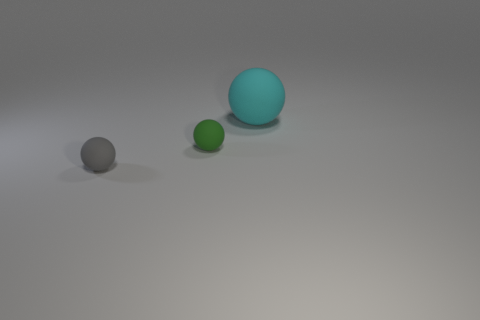Add 1 green rubber things. How many objects exist? 4 Subtract all large cyan matte things. Subtract all small blue cubes. How many objects are left? 2 Add 2 large objects. How many large objects are left? 3 Add 2 gray metal cylinders. How many gray metal cylinders exist? 2 Subtract 0 green blocks. How many objects are left? 3 